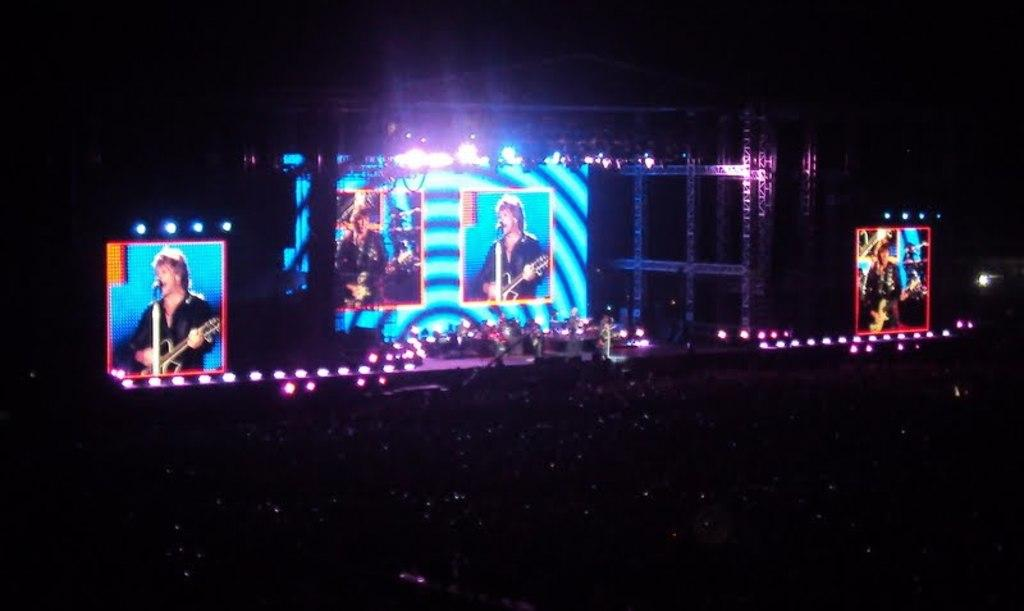What is the main feature of the image? There are many lights in the image. Can you describe the people on the stage? There are few people on the stage. What is located at the back of the stage? There are multiple screens at the back of the stage. What color is the background of the image? The background of the image is black. What type of weather can be seen in the image? There is no weather depicted in the image, as it is an indoor scene with a black background. Is there a house visible in the image? There is no house present in the image; it features a stage with lights, people, and screens. 